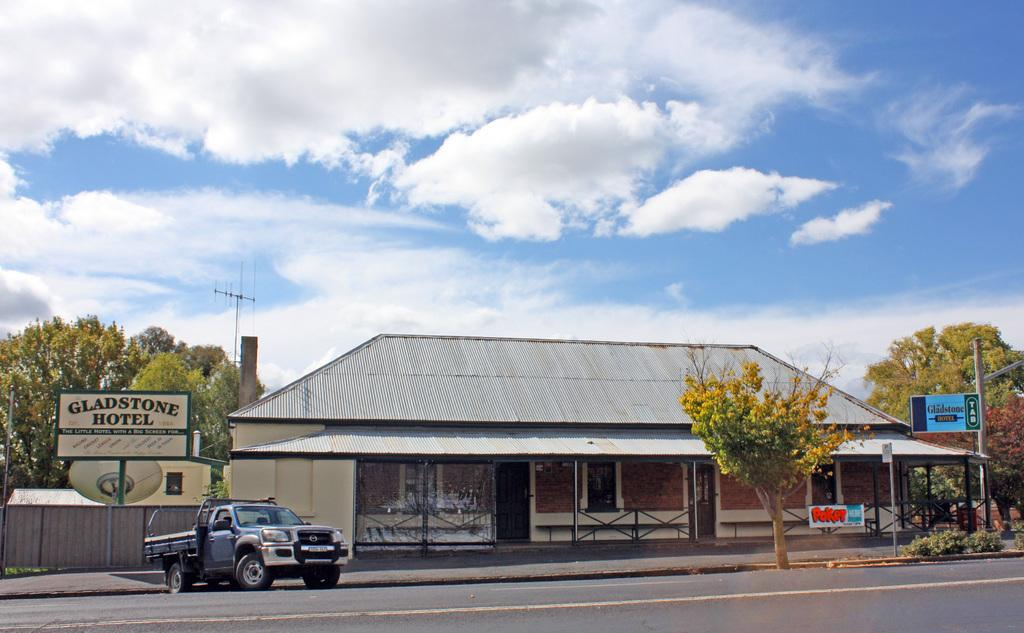What type of structure can be seen in the image? There is a building in the image. What natural element is present in the image? There is a tree in the image. What man-made object provides information or direction in the image? There is a sign board in the image. What type of vegetation is present in the image besides the tree? There are plants in the image. What mode of transportation is visible in the image? There is a vehicle in the image. What type of surface is the vehicle traveling on? There is a road in the image. What part of the natural environment is visible in the image? The sky is visible in the image. What atmospheric feature can be seen in the sky? There are clouds in the sky. What type of connection can be seen between the building and the tree in the image? There is no direct connection between the building and the tree in the image. What type of cherry is used to decorate the plants in the image? There are no cherries present in the image; it only features plants. 